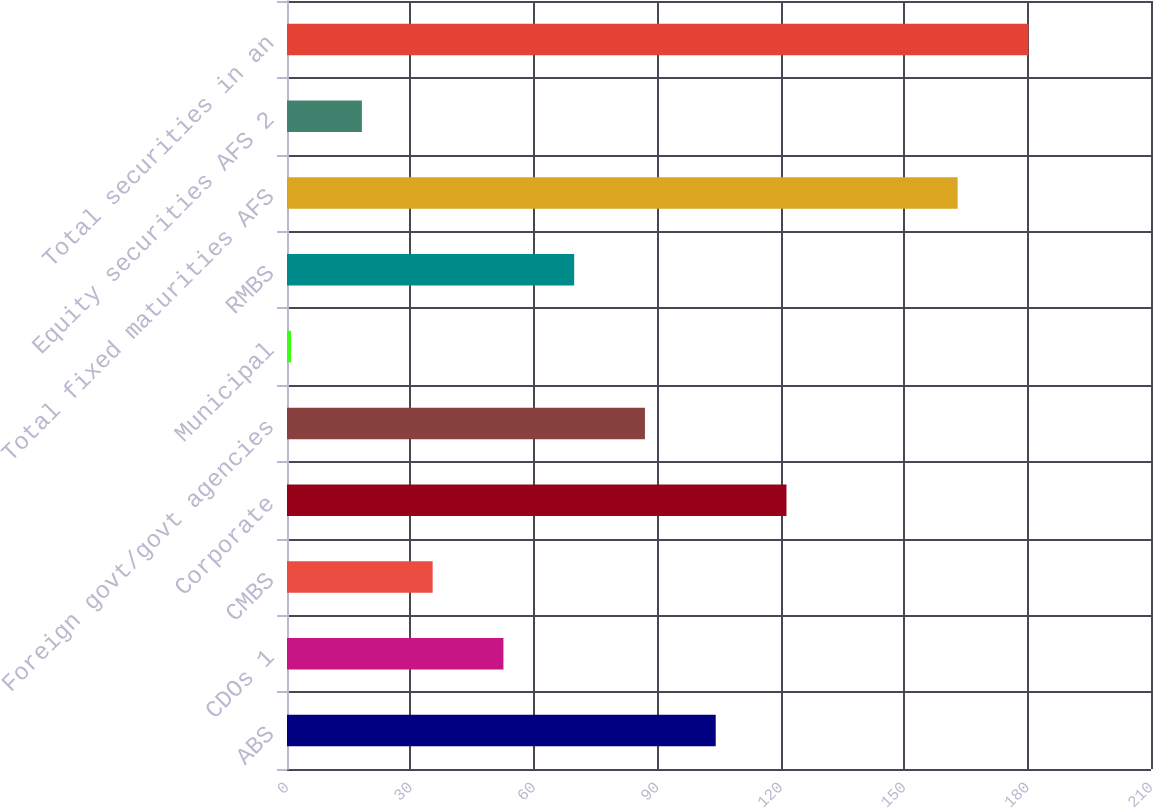<chart> <loc_0><loc_0><loc_500><loc_500><bar_chart><fcel>ABS<fcel>CDOs 1<fcel>CMBS<fcel>Corporate<fcel>Foreign govt/govt agencies<fcel>Municipal<fcel>RMBS<fcel>Total fixed maturities AFS<fcel>Equity securities AFS 2<fcel>Total securities in an<nl><fcel>104.2<fcel>52.6<fcel>35.4<fcel>121.4<fcel>87<fcel>1<fcel>69.8<fcel>163<fcel>18.2<fcel>180.2<nl></chart> 